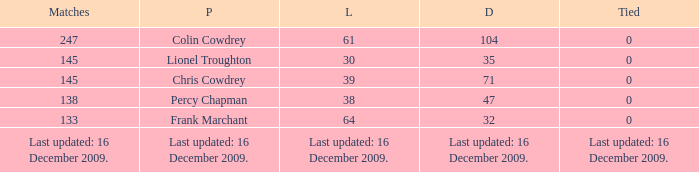Tell me the lost with tie of 0 and drawn of 47 38.0. 